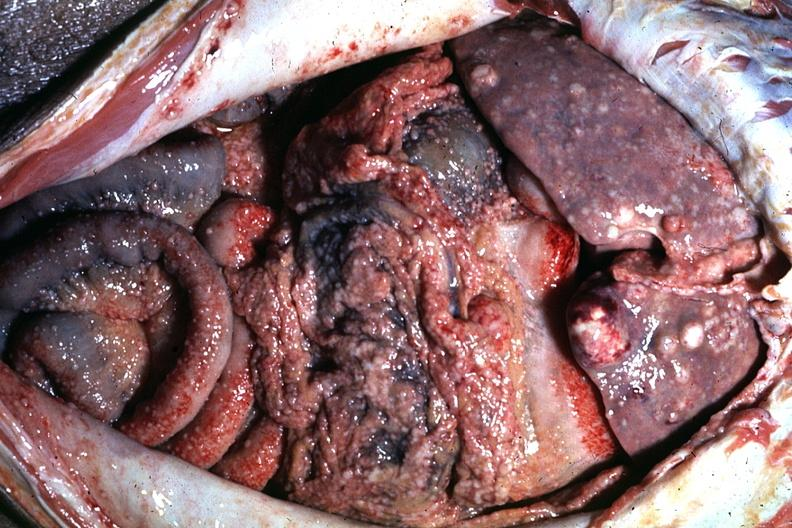s subdiaphragmatic abscess present?
Answer the question using a single word or phrase. No 